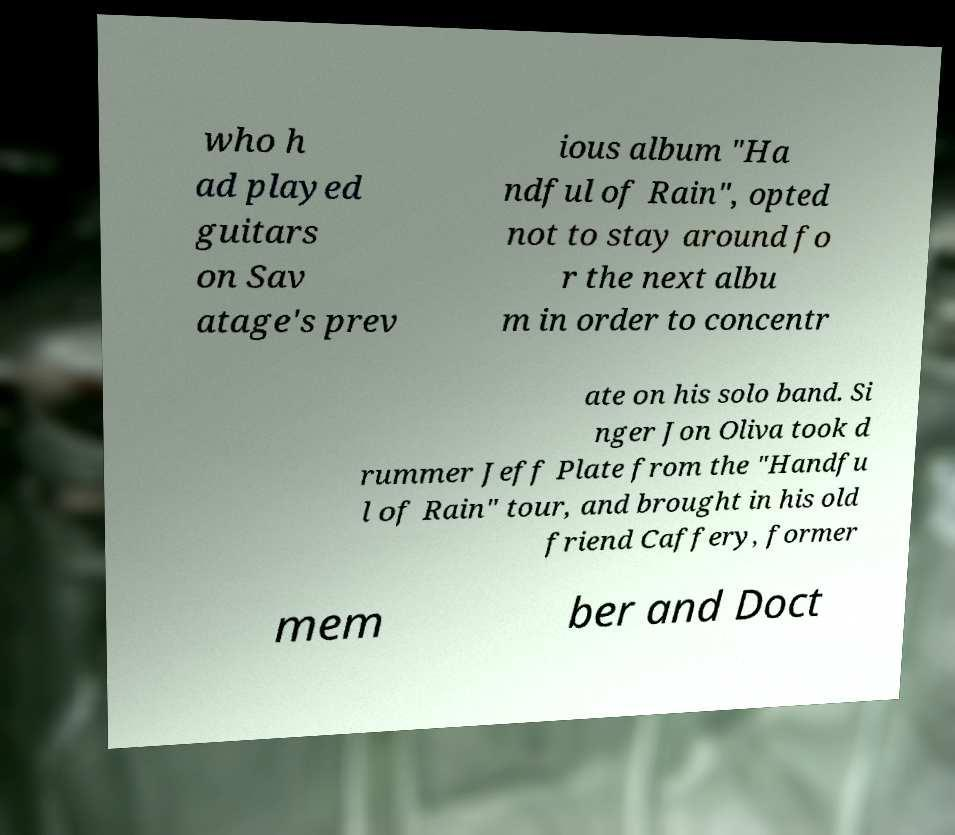For documentation purposes, I need the text within this image transcribed. Could you provide that? who h ad played guitars on Sav atage's prev ious album "Ha ndful of Rain", opted not to stay around fo r the next albu m in order to concentr ate on his solo band. Si nger Jon Oliva took d rummer Jeff Plate from the "Handfu l of Rain" tour, and brought in his old friend Caffery, former mem ber and Doct 